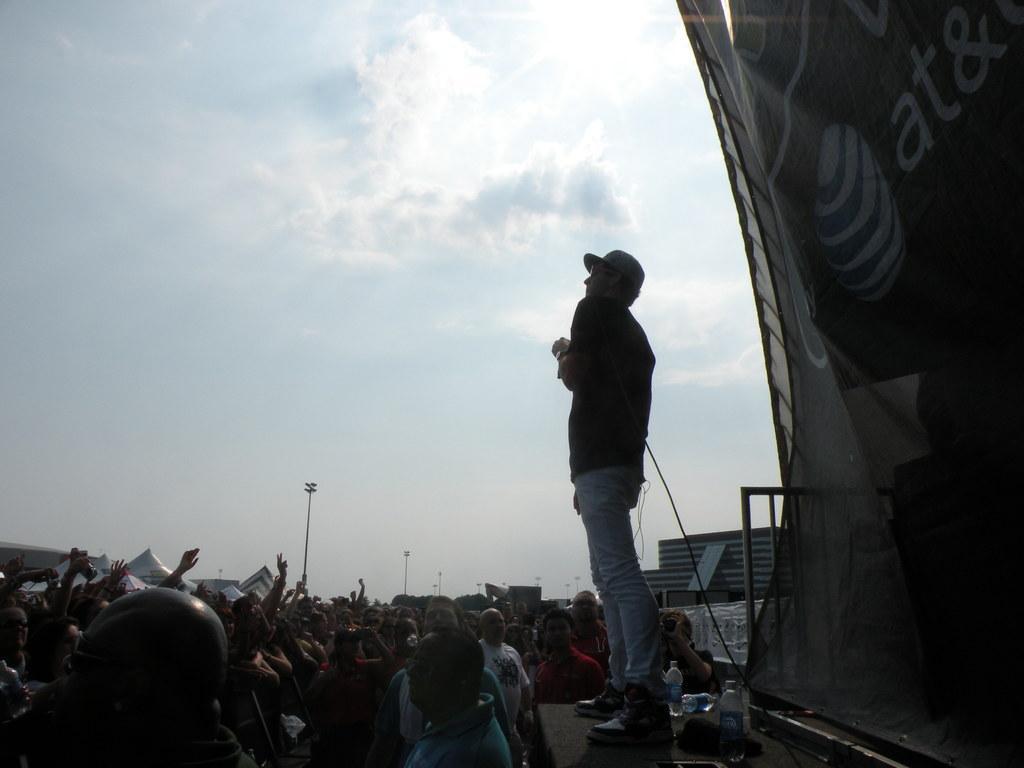Describe this image in one or two sentences. In this image we can see a person wearing goggles and cap. He is standing near to him. There are bottles. On the right side there is a railing. Also there is a cloth on the right side. Near to him there are many people. In the background there is sky with clouds. 